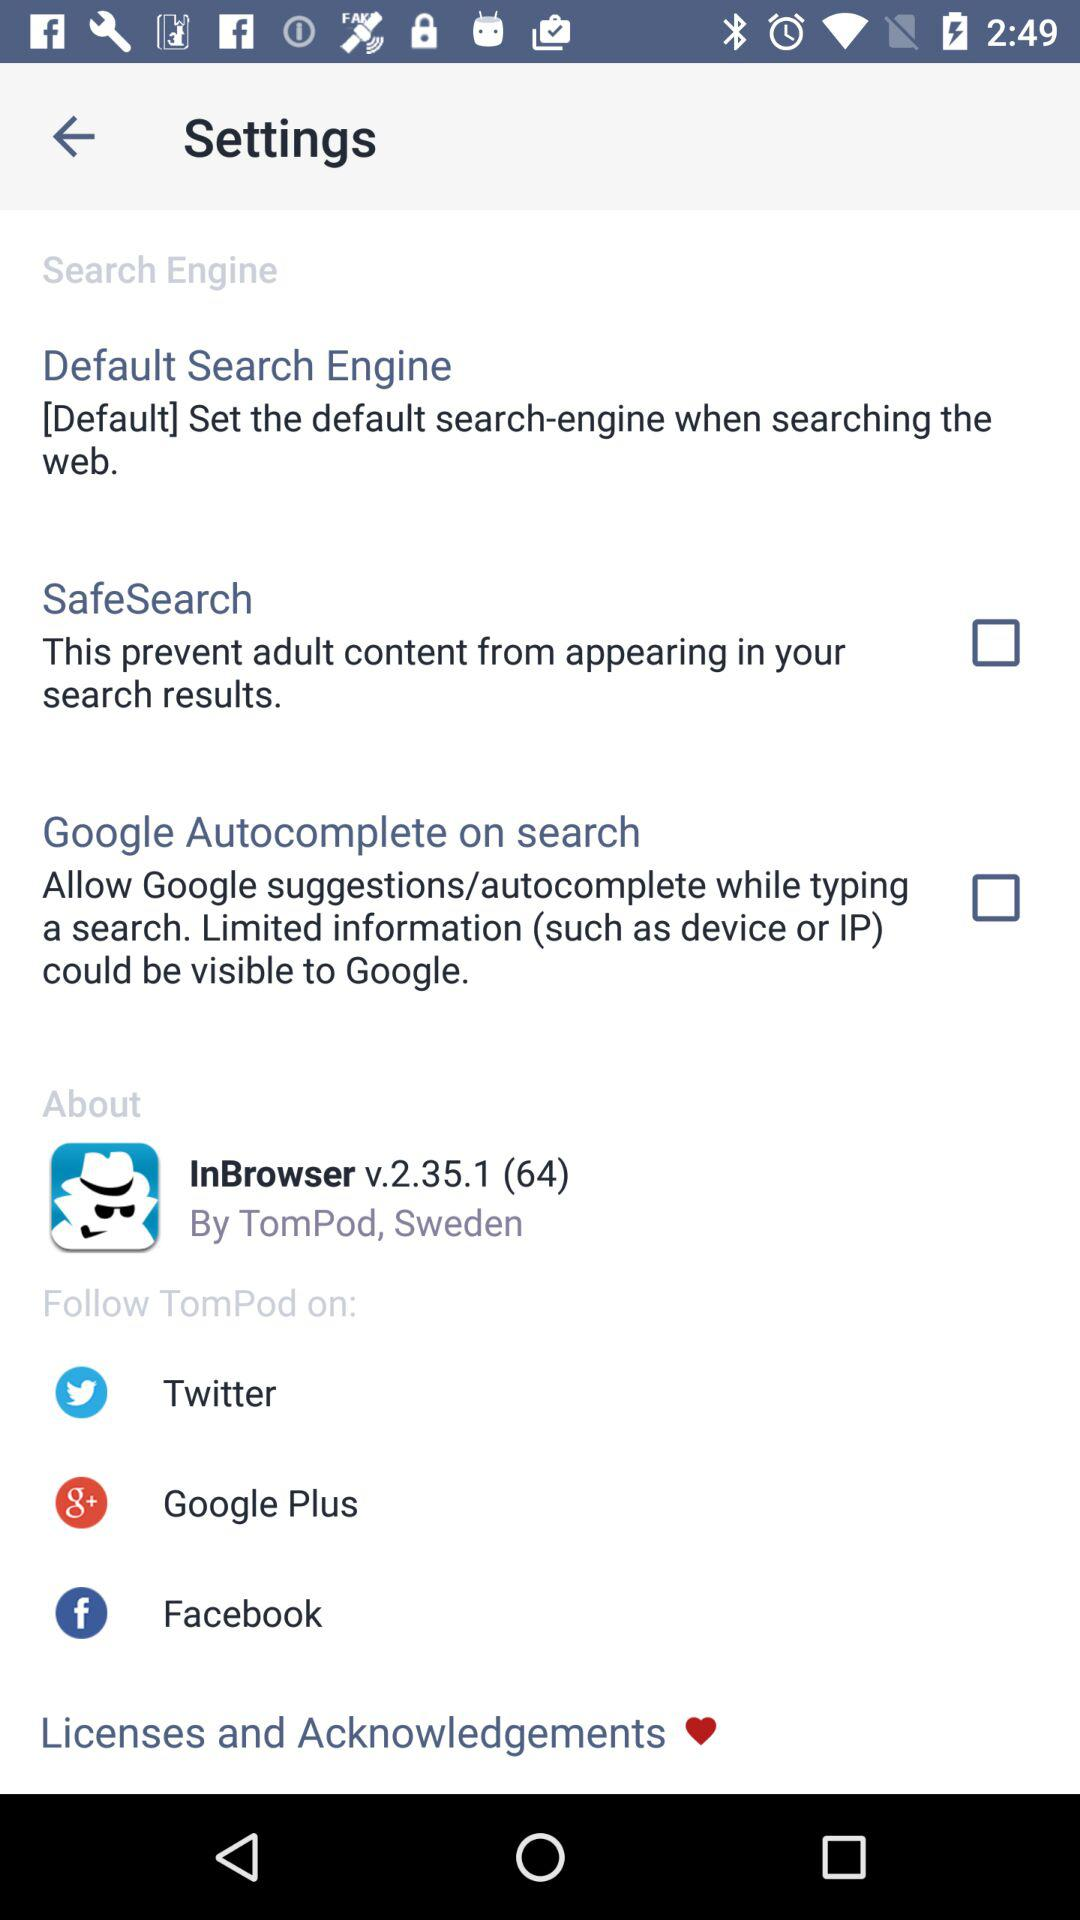Where is the developer located? The developer is located in Sweden. 